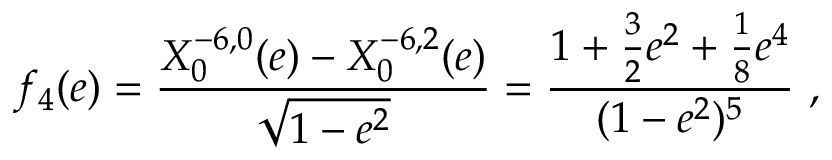Convert formula to latex. <formula><loc_0><loc_0><loc_500><loc_500>f _ { 4 } ( e ) = \frac { X _ { 0 } ^ { - 6 , 0 } ( e ) - X _ { 0 } ^ { - 6 , 2 } ( e ) } { \sqrt { 1 - e ^ { 2 } } } = \frac { 1 + \frac { 3 } { 2 } e ^ { 2 } + \frac { 1 } { 8 } e ^ { 4 } } { ( 1 - e ^ { 2 } ) ^ { 5 } } \ ,</formula> 